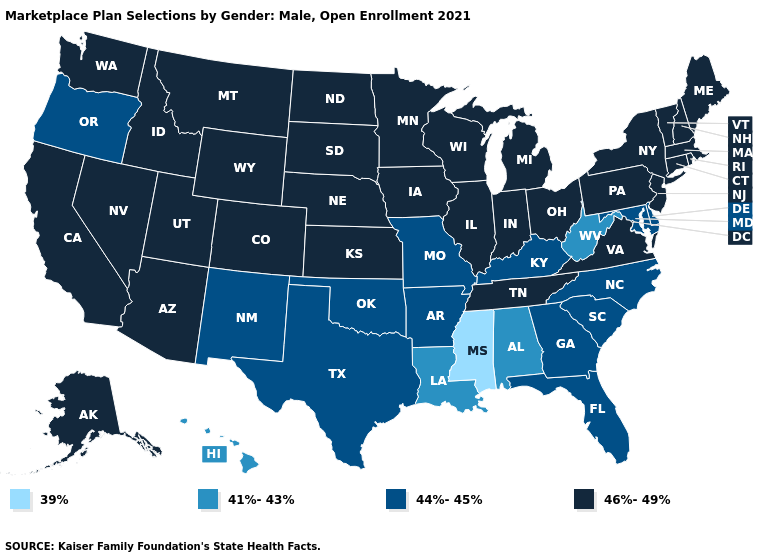Name the states that have a value in the range 46%-49%?
Quick response, please. Alaska, Arizona, California, Colorado, Connecticut, Idaho, Illinois, Indiana, Iowa, Kansas, Maine, Massachusetts, Michigan, Minnesota, Montana, Nebraska, Nevada, New Hampshire, New Jersey, New York, North Dakota, Ohio, Pennsylvania, Rhode Island, South Dakota, Tennessee, Utah, Vermont, Virginia, Washington, Wisconsin, Wyoming. Among the states that border Kentucky , which have the highest value?
Give a very brief answer. Illinois, Indiana, Ohio, Tennessee, Virginia. Does Delaware have a higher value than Louisiana?
Concise answer only. Yes. Name the states that have a value in the range 46%-49%?
Answer briefly. Alaska, Arizona, California, Colorado, Connecticut, Idaho, Illinois, Indiana, Iowa, Kansas, Maine, Massachusetts, Michigan, Minnesota, Montana, Nebraska, Nevada, New Hampshire, New Jersey, New York, North Dakota, Ohio, Pennsylvania, Rhode Island, South Dakota, Tennessee, Utah, Vermont, Virginia, Washington, Wisconsin, Wyoming. Does Kentucky have a higher value than Alabama?
Answer briefly. Yes. What is the value of Wisconsin?
Write a very short answer. 46%-49%. Does California have the highest value in the West?
Answer briefly. Yes. Which states have the highest value in the USA?
Answer briefly. Alaska, Arizona, California, Colorado, Connecticut, Idaho, Illinois, Indiana, Iowa, Kansas, Maine, Massachusetts, Michigan, Minnesota, Montana, Nebraska, Nevada, New Hampshire, New Jersey, New York, North Dakota, Ohio, Pennsylvania, Rhode Island, South Dakota, Tennessee, Utah, Vermont, Virginia, Washington, Wisconsin, Wyoming. Name the states that have a value in the range 44%-45%?
Keep it brief. Arkansas, Delaware, Florida, Georgia, Kentucky, Maryland, Missouri, New Mexico, North Carolina, Oklahoma, Oregon, South Carolina, Texas. Is the legend a continuous bar?
Write a very short answer. No. How many symbols are there in the legend?
Write a very short answer. 4. What is the lowest value in states that border Pennsylvania?
Keep it brief. 41%-43%. What is the value of Connecticut?
Quick response, please. 46%-49%. Name the states that have a value in the range 39%?
Write a very short answer. Mississippi. Among the states that border Idaho , does Oregon have the lowest value?
Short answer required. Yes. 